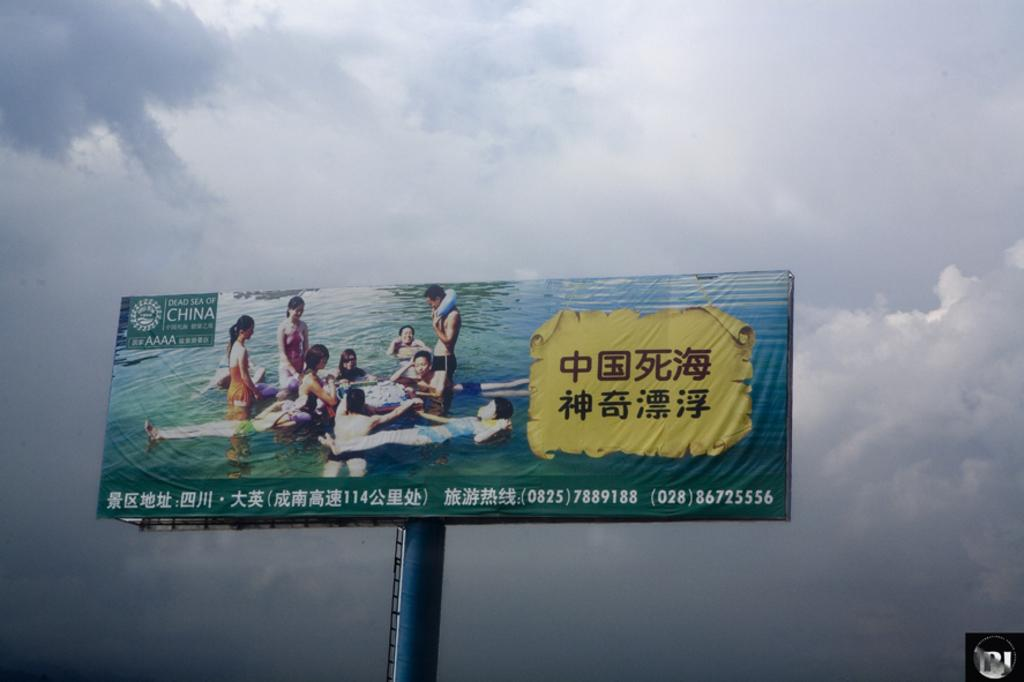<image>
Share a concise interpretation of the image provided. A tall billboard with an advertisement of a family in the water  and has China written at the top/ 